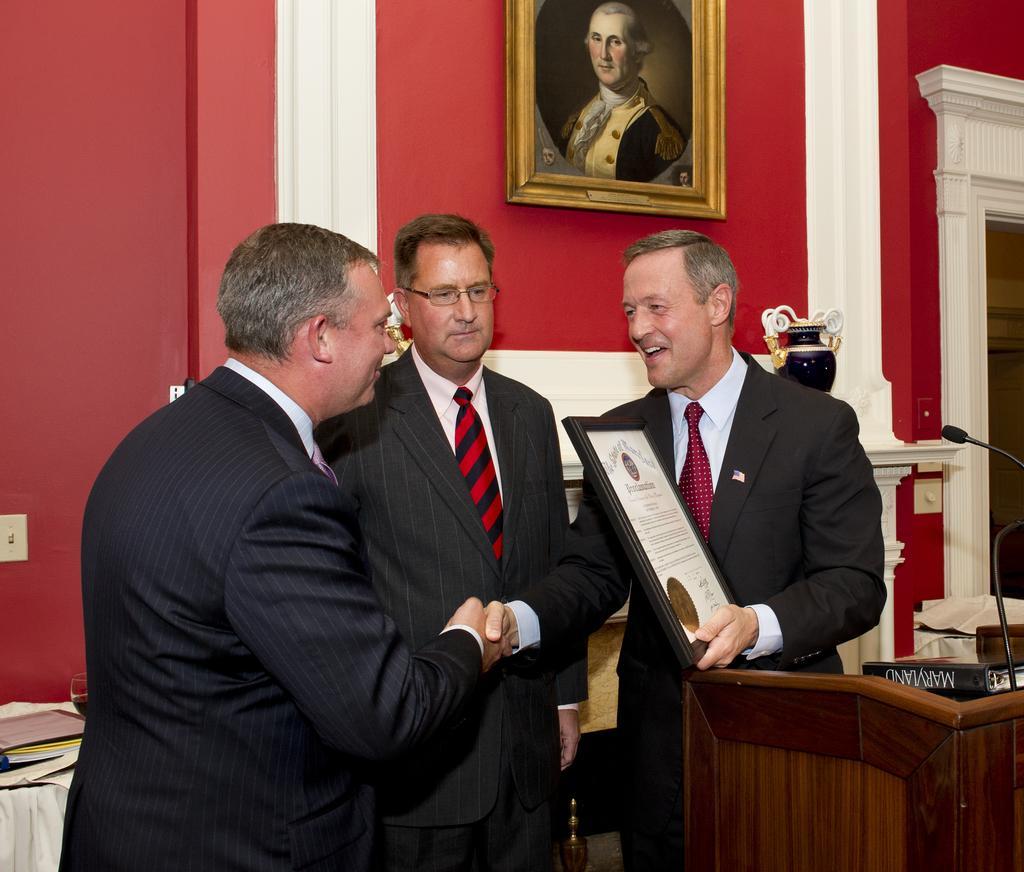In one or two sentences, can you explain what this image depicts? In the image on the right side there is a podium with mic and book. Beside the podium there is a man standing and holding a frame in his hand. And also there are two men standing. Behind them there is a wall with a photo frame. In the left bottom of the image there is a table with books. 